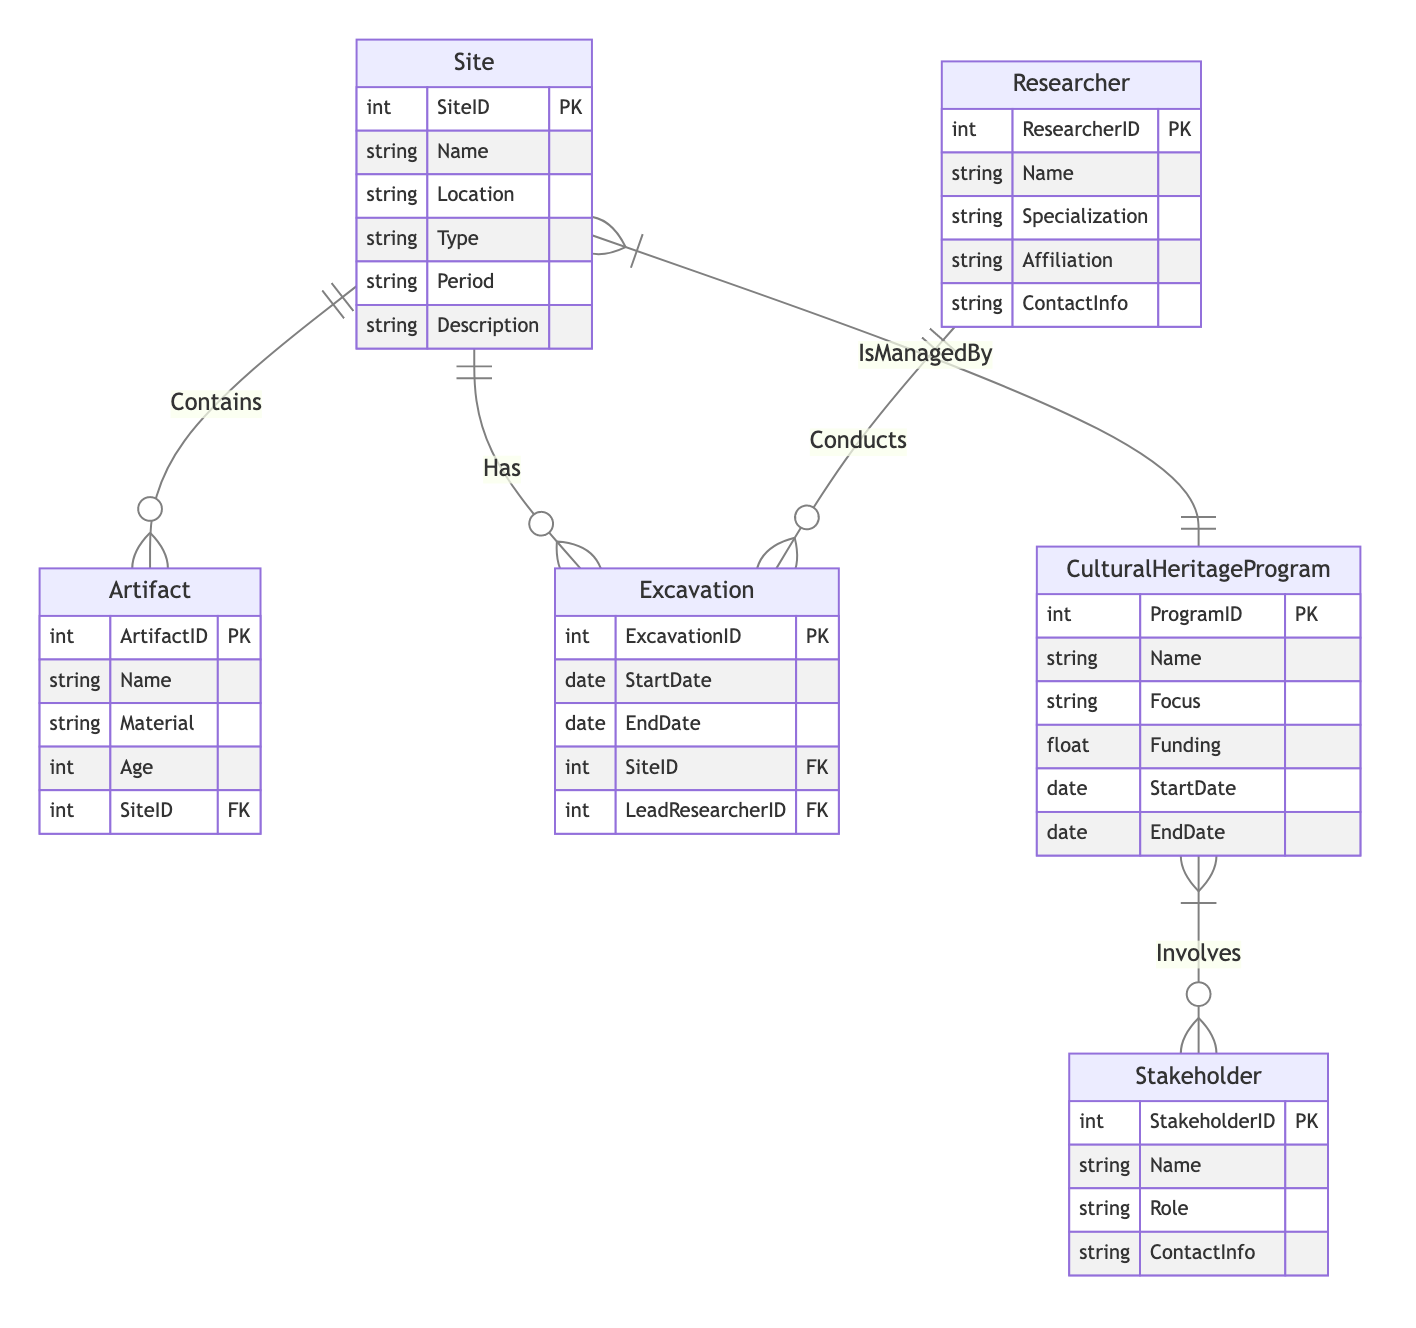What is the primary key of the Site entity? The primary key of the Site entity is SiteID, which uniquely identifies each site in the database.
Answer: SiteID How many relationships are there in the diagram? There are five relationships shown in the diagram, connecting the different entities.
Answer: 5 Which entity is involved in the Conducts relationship? The Conducts relationship involves the Researcher entity, which indicates that researchers conduct excavations.
Answer: Researcher What is the relationship between Site and Artifact? The relationship between Site and Artifact is defined by the Contains relationship, which signifies that a site can contain multiple artifacts.
Answer: Contains Who leads the Excavation? The LeadResearcherID in the Excavation entity indicates which researcher leads the excavation, showing the relationship between excavations and researchers.
Answer: LeadResearcherID How many attributes does the Cultural Heritage Program have? The Cultural Heritage Program entity has six attributes listed, detailing various aspects of the program.
Answer: 6 What is the focus of the Cultural Heritage Program? The focus is specified as a property in the Cultural Heritage Program entity, indicating the specific area or issue the program addresses.
Answer: Focus Which entity manages the Site? The Site is managed by the Cultural Heritage Program, as indicated by the IsManagedBy relationship.
Answer: Cultural Heritage Program What is the role of the Stakeholder in the Cultural Heritage Program? The Stakeholder's role in the Cultural Heritage Program is described as Involves, indicating their participation in managing or supporting cultural heritage activities.
Answer: Involves 